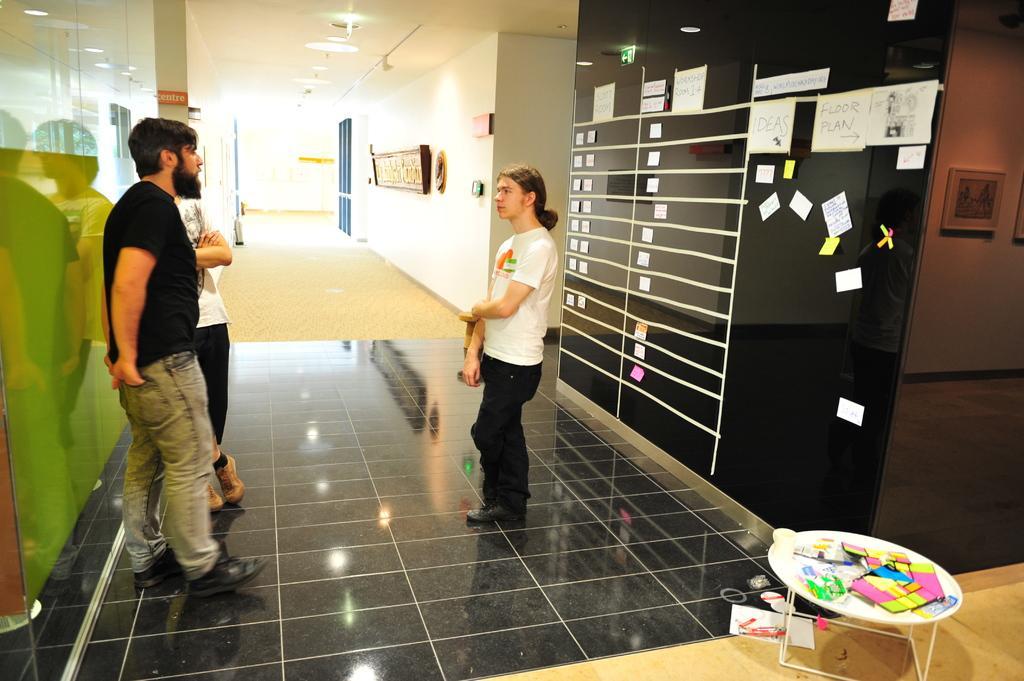How would you summarize this image in a sentence or two? In this picture I can observe three members standing on the floor. On the right side I can observe a table on which some watercolors are placed. I can observe black color wall on which papers were stuck. In the background I can observe a wall and I can observe some lights in the ceiling. 